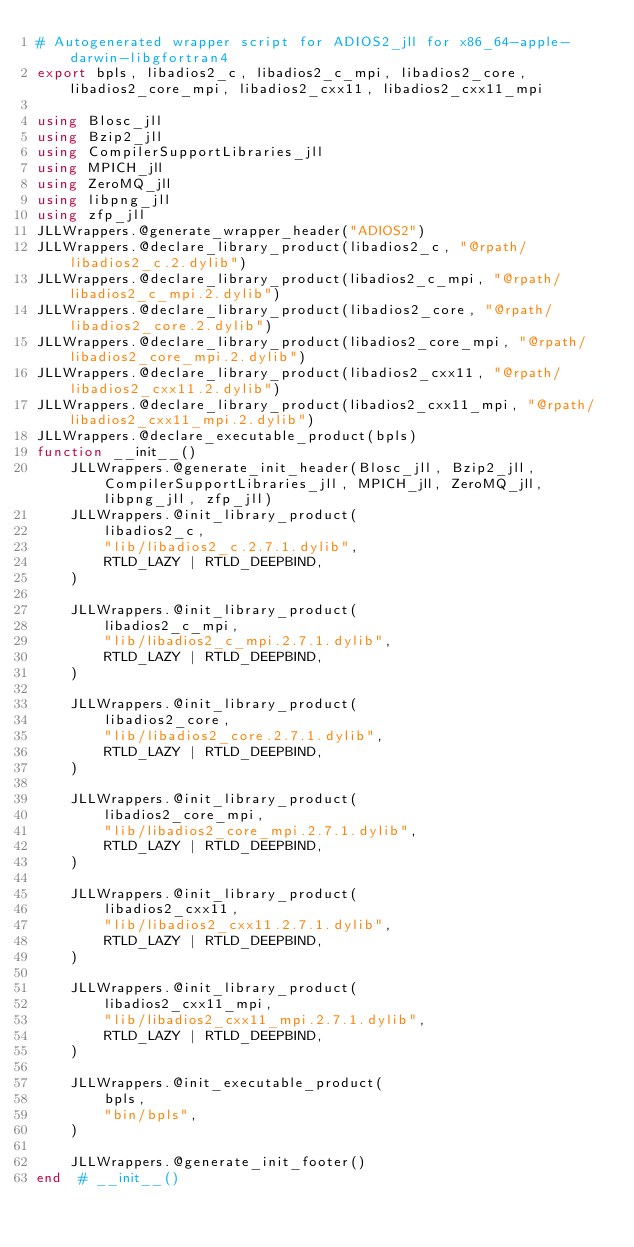Convert code to text. <code><loc_0><loc_0><loc_500><loc_500><_Julia_># Autogenerated wrapper script for ADIOS2_jll for x86_64-apple-darwin-libgfortran4
export bpls, libadios2_c, libadios2_c_mpi, libadios2_core, libadios2_core_mpi, libadios2_cxx11, libadios2_cxx11_mpi

using Blosc_jll
using Bzip2_jll
using CompilerSupportLibraries_jll
using MPICH_jll
using ZeroMQ_jll
using libpng_jll
using zfp_jll
JLLWrappers.@generate_wrapper_header("ADIOS2")
JLLWrappers.@declare_library_product(libadios2_c, "@rpath/libadios2_c.2.dylib")
JLLWrappers.@declare_library_product(libadios2_c_mpi, "@rpath/libadios2_c_mpi.2.dylib")
JLLWrappers.@declare_library_product(libadios2_core, "@rpath/libadios2_core.2.dylib")
JLLWrappers.@declare_library_product(libadios2_core_mpi, "@rpath/libadios2_core_mpi.2.dylib")
JLLWrappers.@declare_library_product(libadios2_cxx11, "@rpath/libadios2_cxx11.2.dylib")
JLLWrappers.@declare_library_product(libadios2_cxx11_mpi, "@rpath/libadios2_cxx11_mpi.2.dylib")
JLLWrappers.@declare_executable_product(bpls)
function __init__()
    JLLWrappers.@generate_init_header(Blosc_jll, Bzip2_jll, CompilerSupportLibraries_jll, MPICH_jll, ZeroMQ_jll, libpng_jll, zfp_jll)
    JLLWrappers.@init_library_product(
        libadios2_c,
        "lib/libadios2_c.2.7.1.dylib",
        RTLD_LAZY | RTLD_DEEPBIND,
    )

    JLLWrappers.@init_library_product(
        libadios2_c_mpi,
        "lib/libadios2_c_mpi.2.7.1.dylib",
        RTLD_LAZY | RTLD_DEEPBIND,
    )

    JLLWrappers.@init_library_product(
        libadios2_core,
        "lib/libadios2_core.2.7.1.dylib",
        RTLD_LAZY | RTLD_DEEPBIND,
    )

    JLLWrappers.@init_library_product(
        libadios2_core_mpi,
        "lib/libadios2_core_mpi.2.7.1.dylib",
        RTLD_LAZY | RTLD_DEEPBIND,
    )

    JLLWrappers.@init_library_product(
        libadios2_cxx11,
        "lib/libadios2_cxx11.2.7.1.dylib",
        RTLD_LAZY | RTLD_DEEPBIND,
    )

    JLLWrappers.@init_library_product(
        libadios2_cxx11_mpi,
        "lib/libadios2_cxx11_mpi.2.7.1.dylib",
        RTLD_LAZY | RTLD_DEEPBIND,
    )

    JLLWrappers.@init_executable_product(
        bpls,
        "bin/bpls",
    )

    JLLWrappers.@generate_init_footer()
end  # __init__()
</code> 